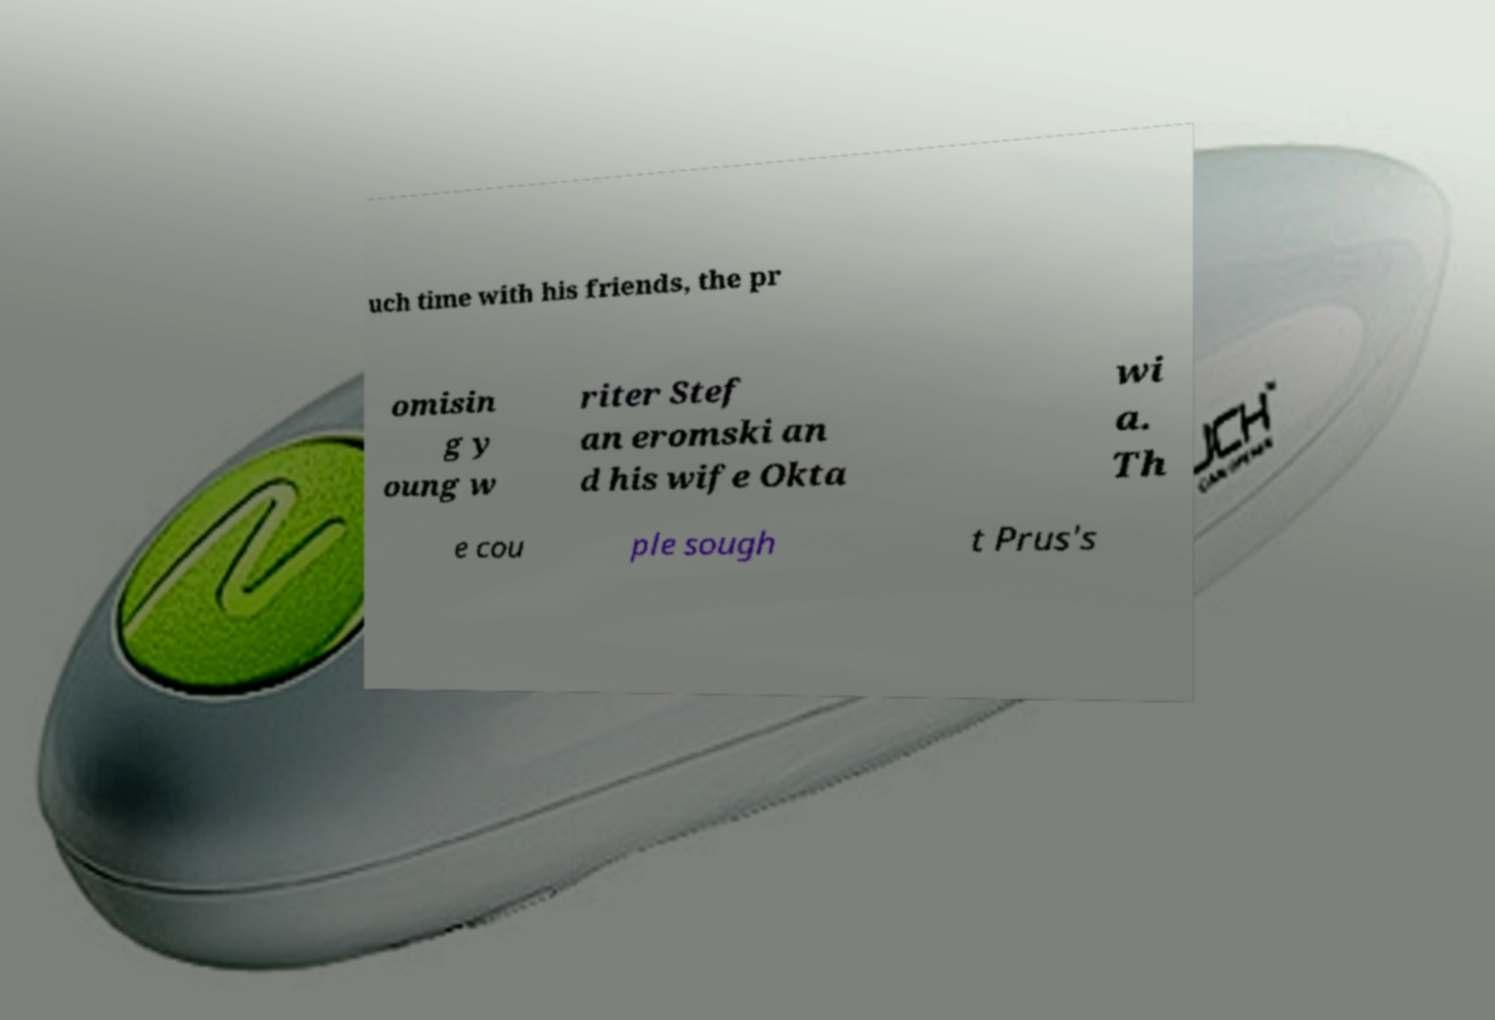There's text embedded in this image that I need extracted. Can you transcribe it verbatim? uch time with his friends, the pr omisin g y oung w riter Stef an eromski an d his wife Okta wi a. Th e cou ple sough t Prus's 